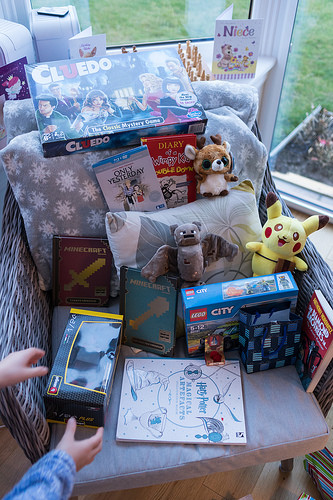<image>
Can you confirm if the card is on the chair? Yes. Looking at the image, I can see the card is positioned on top of the chair, with the chair providing support. 